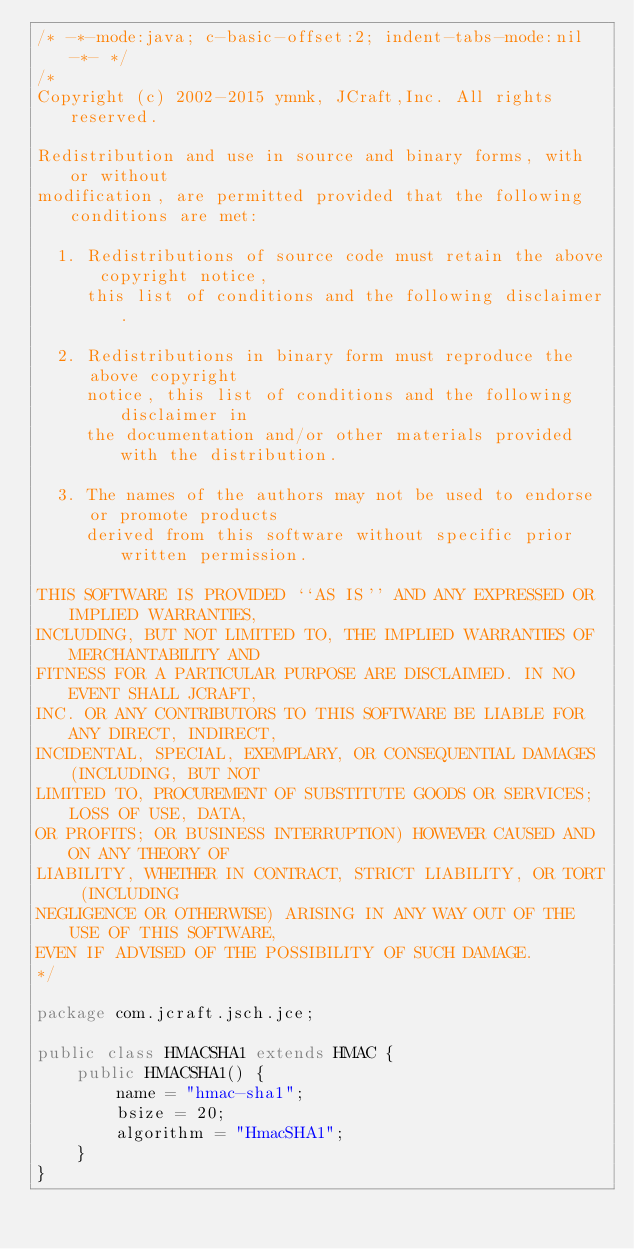<code> <loc_0><loc_0><loc_500><loc_500><_Java_>/* -*-mode:java; c-basic-offset:2; indent-tabs-mode:nil -*- */
/*
Copyright (c) 2002-2015 ymnk, JCraft,Inc. All rights reserved.

Redistribution and use in source and binary forms, with or without
modification, are permitted provided that the following conditions are met:

  1. Redistributions of source code must retain the above copyright notice,
     this list of conditions and the following disclaimer.

  2. Redistributions in binary form must reproduce the above copyright 
     notice, this list of conditions and the following disclaimer in 
     the documentation and/or other materials provided with the distribution.

  3. The names of the authors may not be used to endorse or promote products
     derived from this software without specific prior written permission.

THIS SOFTWARE IS PROVIDED ``AS IS'' AND ANY EXPRESSED OR IMPLIED WARRANTIES,
INCLUDING, BUT NOT LIMITED TO, THE IMPLIED WARRANTIES OF MERCHANTABILITY AND
FITNESS FOR A PARTICULAR PURPOSE ARE DISCLAIMED. IN NO EVENT SHALL JCRAFT,
INC. OR ANY CONTRIBUTORS TO THIS SOFTWARE BE LIABLE FOR ANY DIRECT, INDIRECT,
INCIDENTAL, SPECIAL, EXEMPLARY, OR CONSEQUENTIAL DAMAGES (INCLUDING, BUT NOT
LIMITED TO, PROCUREMENT OF SUBSTITUTE GOODS OR SERVICES; LOSS OF USE, DATA,
OR PROFITS; OR BUSINESS INTERRUPTION) HOWEVER CAUSED AND ON ANY THEORY OF
LIABILITY, WHETHER IN CONTRACT, STRICT LIABILITY, OR TORT (INCLUDING
NEGLIGENCE OR OTHERWISE) ARISING IN ANY WAY OUT OF THE USE OF THIS SOFTWARE,
EVEN IF ADVISED OF THE POSSIBILITY OF SUCH DAMAGE.
*/

package com.jcraft.jsch.jce;

public class HMACSHA1 extends HMAC {
    public HMACSHA1() {
        name = "hmac-sha1";
        bsize = 20;
        algorithm = "HmacSHA1";
    }
}
</code> 